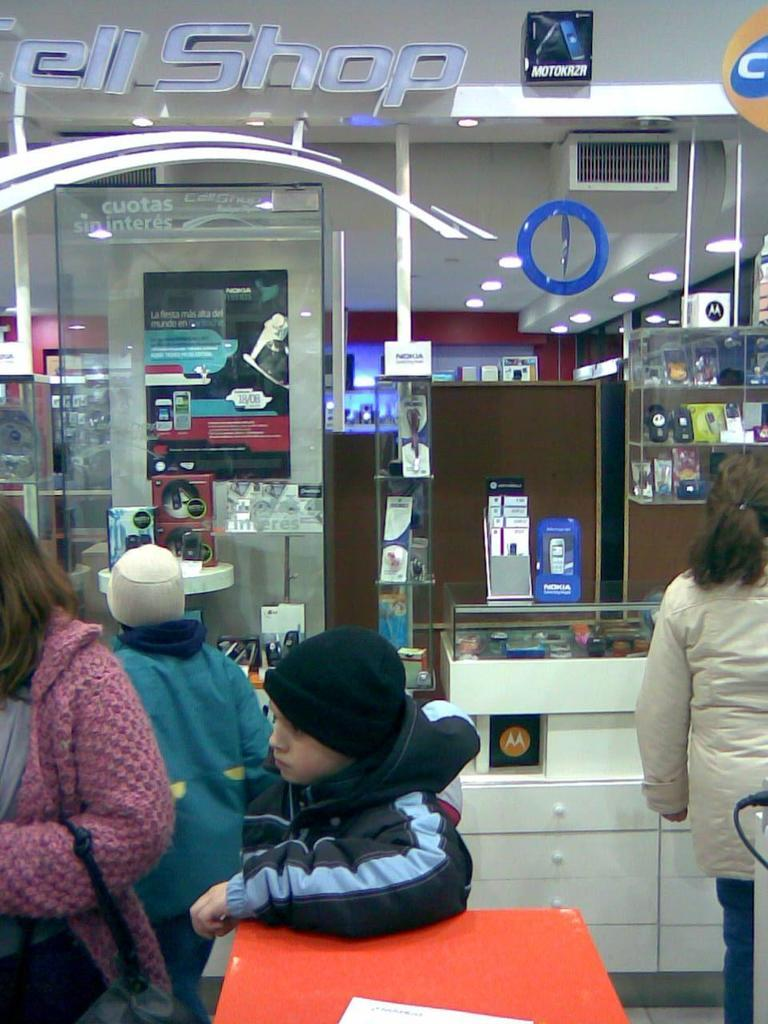Provide a one-sentence caption for the provided image. Customers in a store with the words "ell Shop" visible on top. 